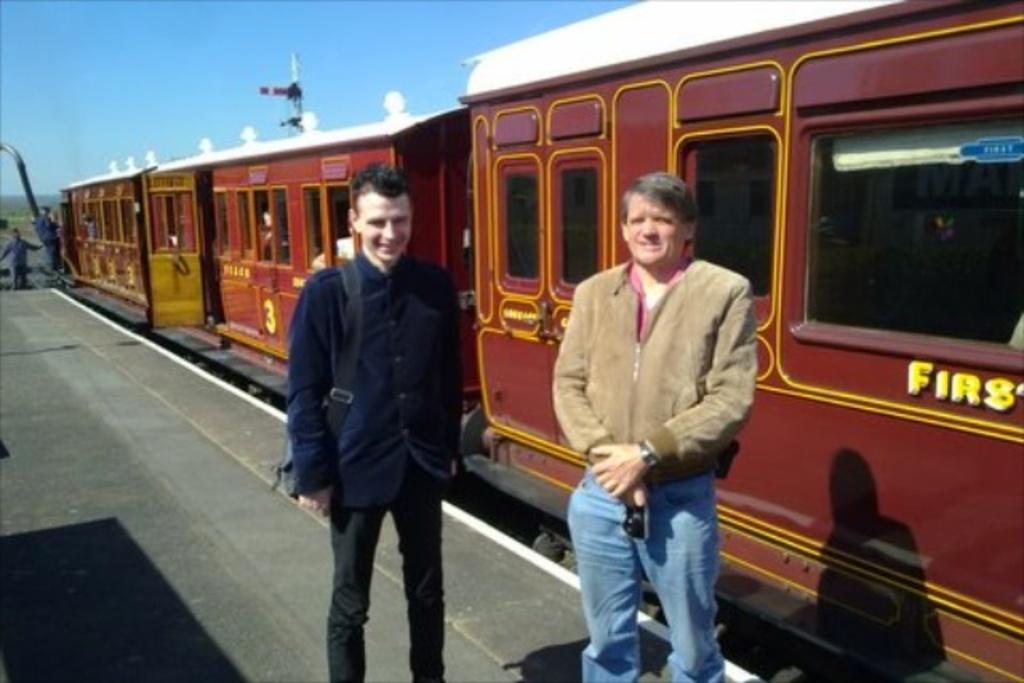What are the people doing in the image? The people are standing on a platform in the image. What can be seen on the track near the platform? There is a train on the track in the image. How would you describe the sky in the image? The sky appears cloudy in the image. Can you tell me how many hens are on the train in the image? There are no hens present on the train in the image. What type of question is being asked by the person standing on the platform? There is no indication in the image that a person is asking a question. 